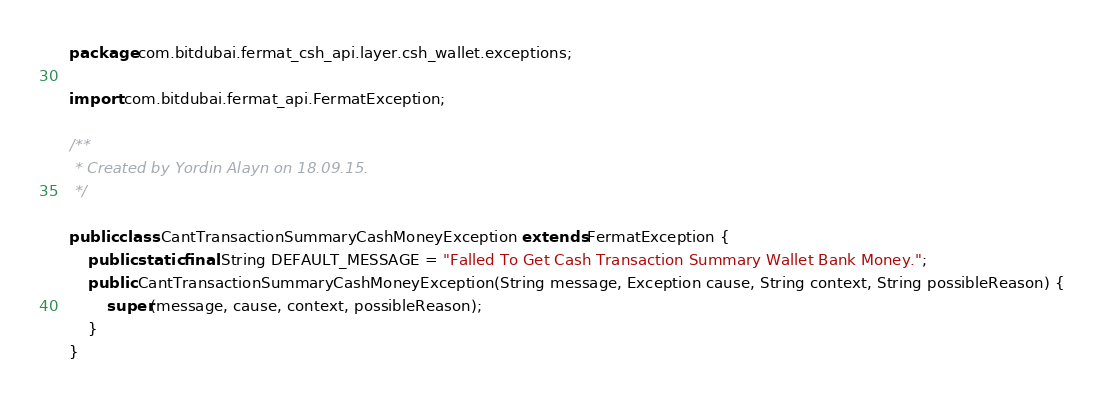Convert code to text. <code><loc_0><loc_0><loc_500><loc_500><_Java_>package com.bitdubai.fermat_csh_api.layer.csh_wallet.exceptions;

import com.bitdubai.fermat_api.FermatException;

/**
 * Created by Yordin Alayn on 18.09.15.
 */

public class CantTransactionSummaryCashMoneyException extends FermatException {
    public static final String DEFAULT_MESSAGE = "Falled To Get Cash Transaction Summary Wallet Bank Money.";
    public CantTransactionSummaryCashMoneyException(String message, Exception cause, String context, String possibleReason) {
        super(message, cause, context, possibleReason);
    }
}
</code> 